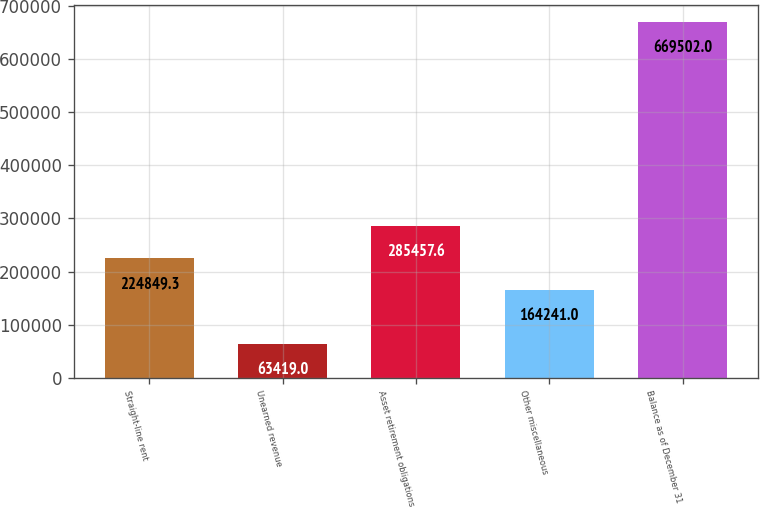Convert chart to OTSL. <chart><loc_0><loc_0><loc_500><loc_500><bar_chart><fcel>Straight-line rent<fcel>Unearned revenue<fcel>Asset retirement obligations<fcel>Other miscellaneous<fcel>Balance as of December 31<nl><fcel>224849<fcel>63419<fcel>285458<fcel>164241<fcel>669502<nl></chart> 